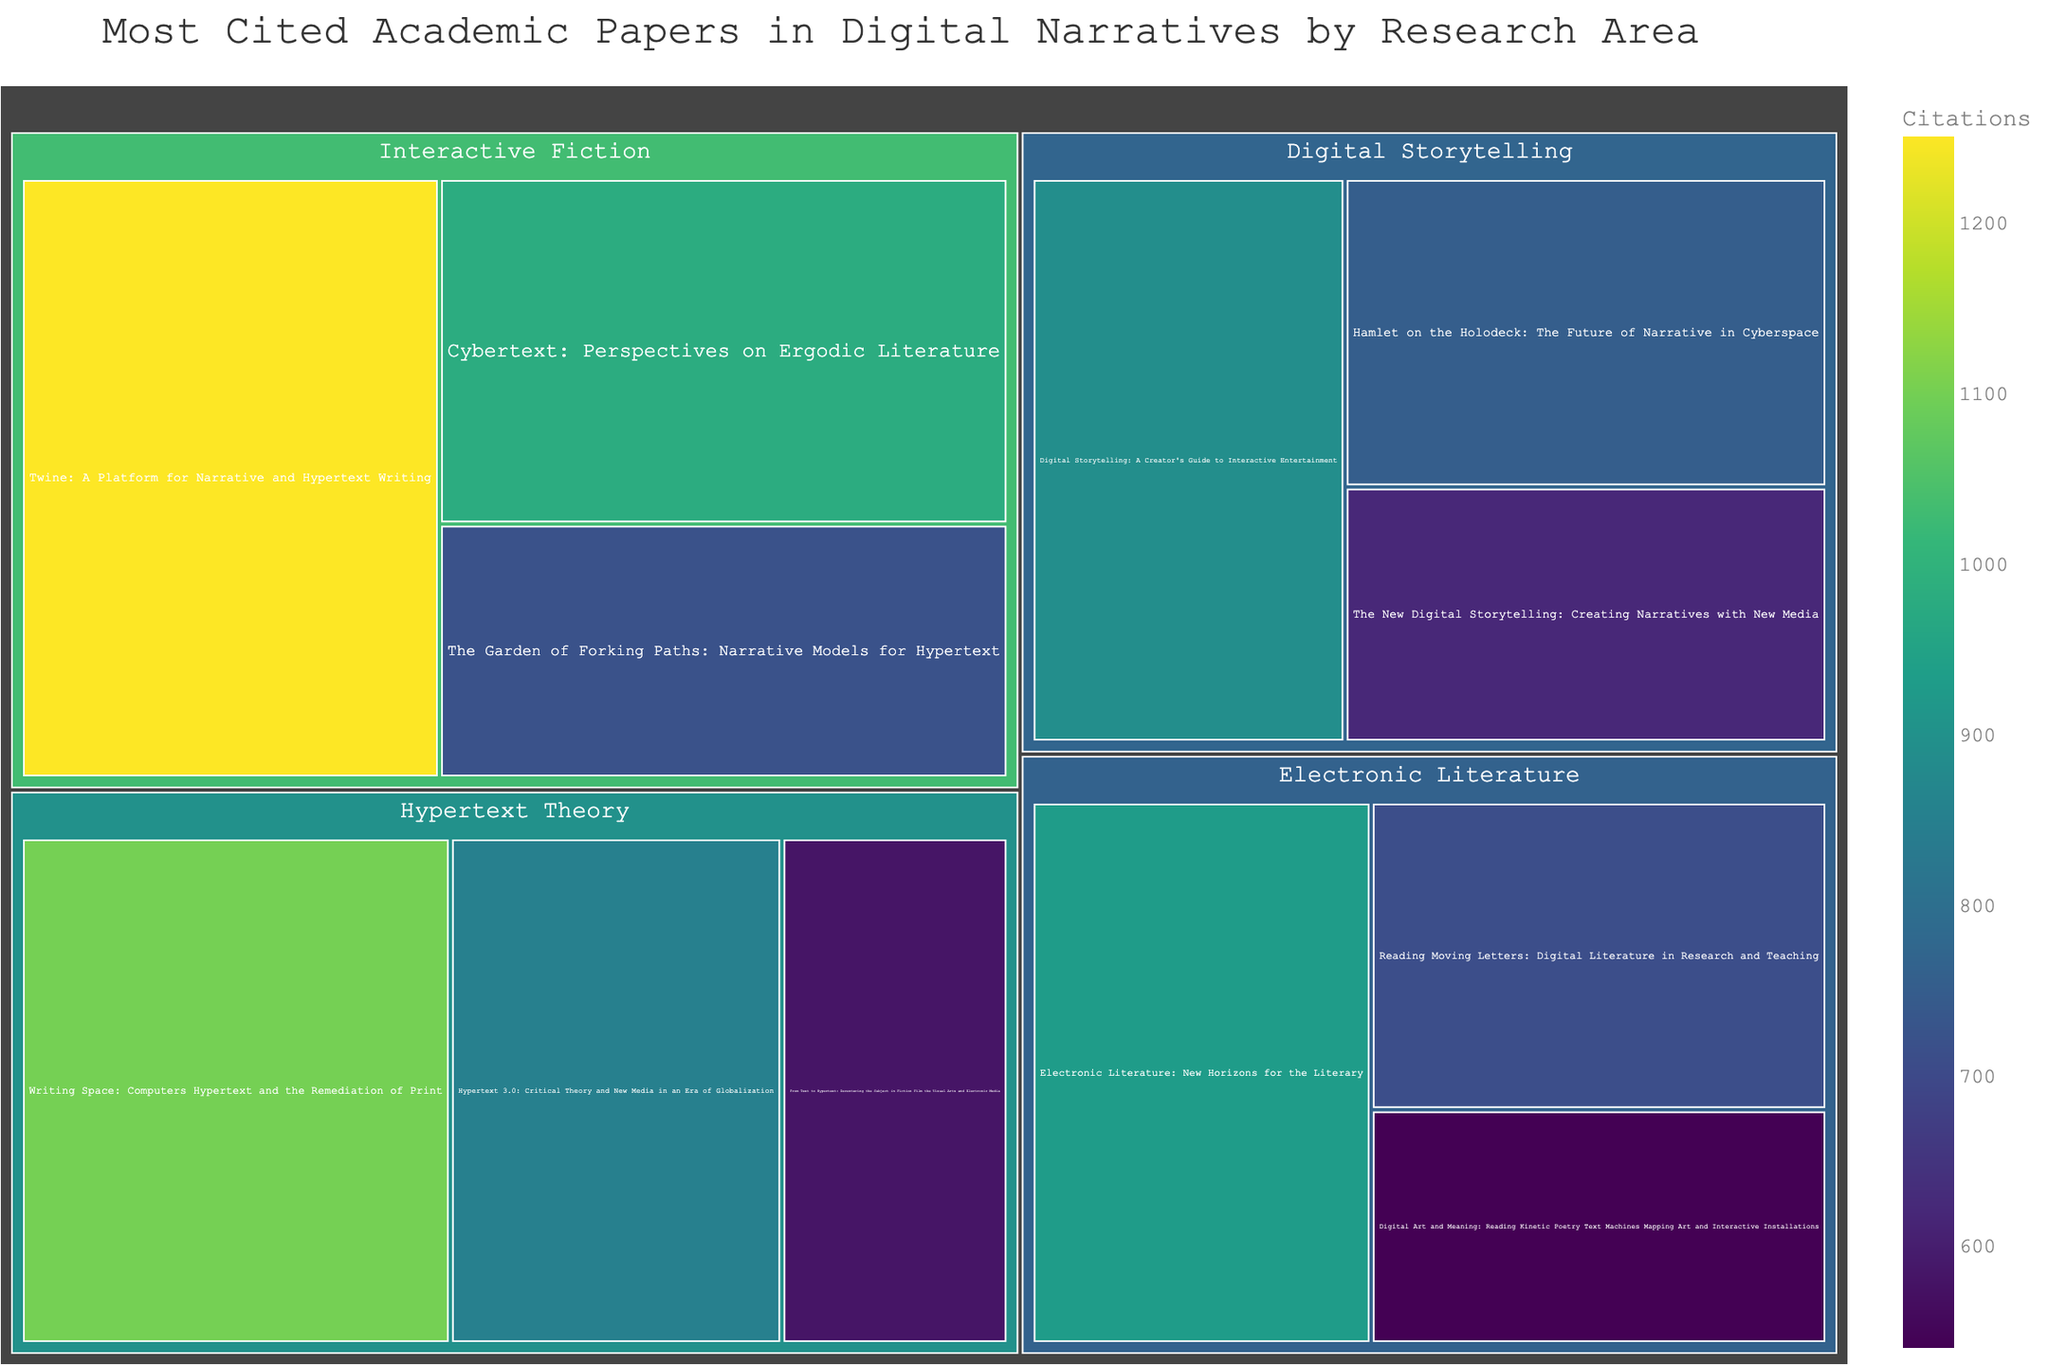What is the most cited paper in the "Interactive Fiction" research area? Look for the area labeled "Interactive Fiction" and identify the paper with the highest number of citations within this area.
Answer: Twine: A Platform for Narrative and Hypertext Writing Which research area has the most cited paper overall? Compare the citation counts of the most cited papers from each research area and identify the highest one.
Answer: Interactive Fiction How many papers in the "Digital Storytelling" research area have more than 600 citations? Look at the "Digital Storytelling" area and count the papers with citations greater than 600.
Answer: Three What is the sum of citations for all papers in "Hypertext Theory"? Add up the citations of all the papers listed under "Hypertext Theory". 1100 (Writing Space) + 850 (Hypertext 3.0) + 580 (From Text to Hypertext). The sum is 2530.
Answer: 2530 Which paper in the "Electronic Literature" research area has the fewest citations? Look in the "Electronic Literature" area and identify the paper with the lowest citation count.
Answer: Digital Art and Meaning: Reading Kinetic Poetry Text Machines Mapping Art and Interactive Installations Which research area has the least variation in citation counts between its papers? Identify the research area where the difference between the highest and lowest citations of its papers is the smallest. Calculate the ranges: Interactive Fiction (1250 - 720), Digital Storytelling (890 - 620), Hypertext Theory (1100 - 580), Electronic Literature (930 - 540). Find the smallest difference.
Answer: Digital Storytelling What is the average number of citations for the papers in "Electronic Literature"? Add up the citations for "Electronic Literature" papers and divide by the number of papers: (930 + 710 + 540) / 3. The average is 2180/3.
Answer: 726.7 Which paper title in "Hypertext Theory" has mid-range citations? List the citation counts for "Hypertext Theory" (1100, 850, 580) and pick the middle value. Identify the paper corresponding to that value.
Answer: Hypertext 3.0: Critical Theory and New Media in an Era of Globalization 